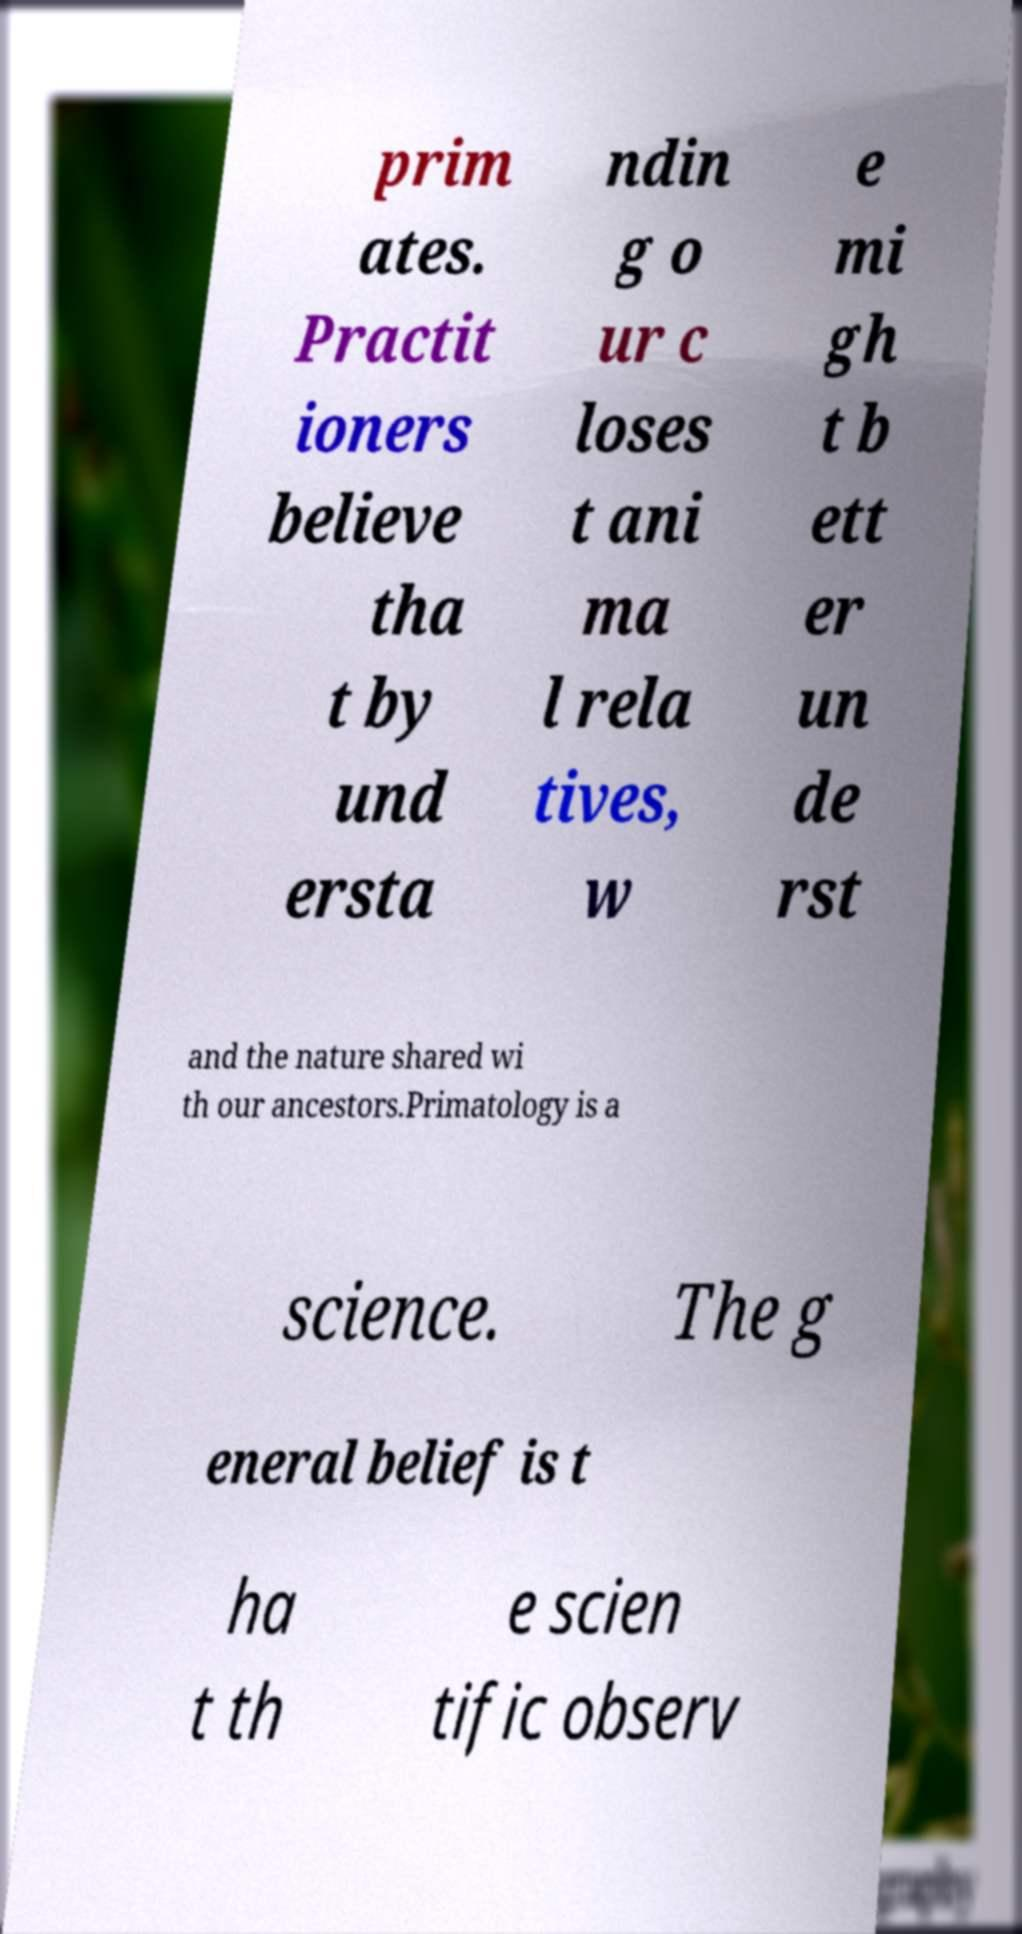Could you assist in decoding the text presented in this image and type it out clearly? prim ates. Practit ioners believe tha t by und ersta ndin g o ur c loses t ani ma l rela tives, w e mi gh t b ett er un de rst and the nature shared wi th our ancestors.Primatology is a science. The g eneral belief is t ha t th e scien tific observ 